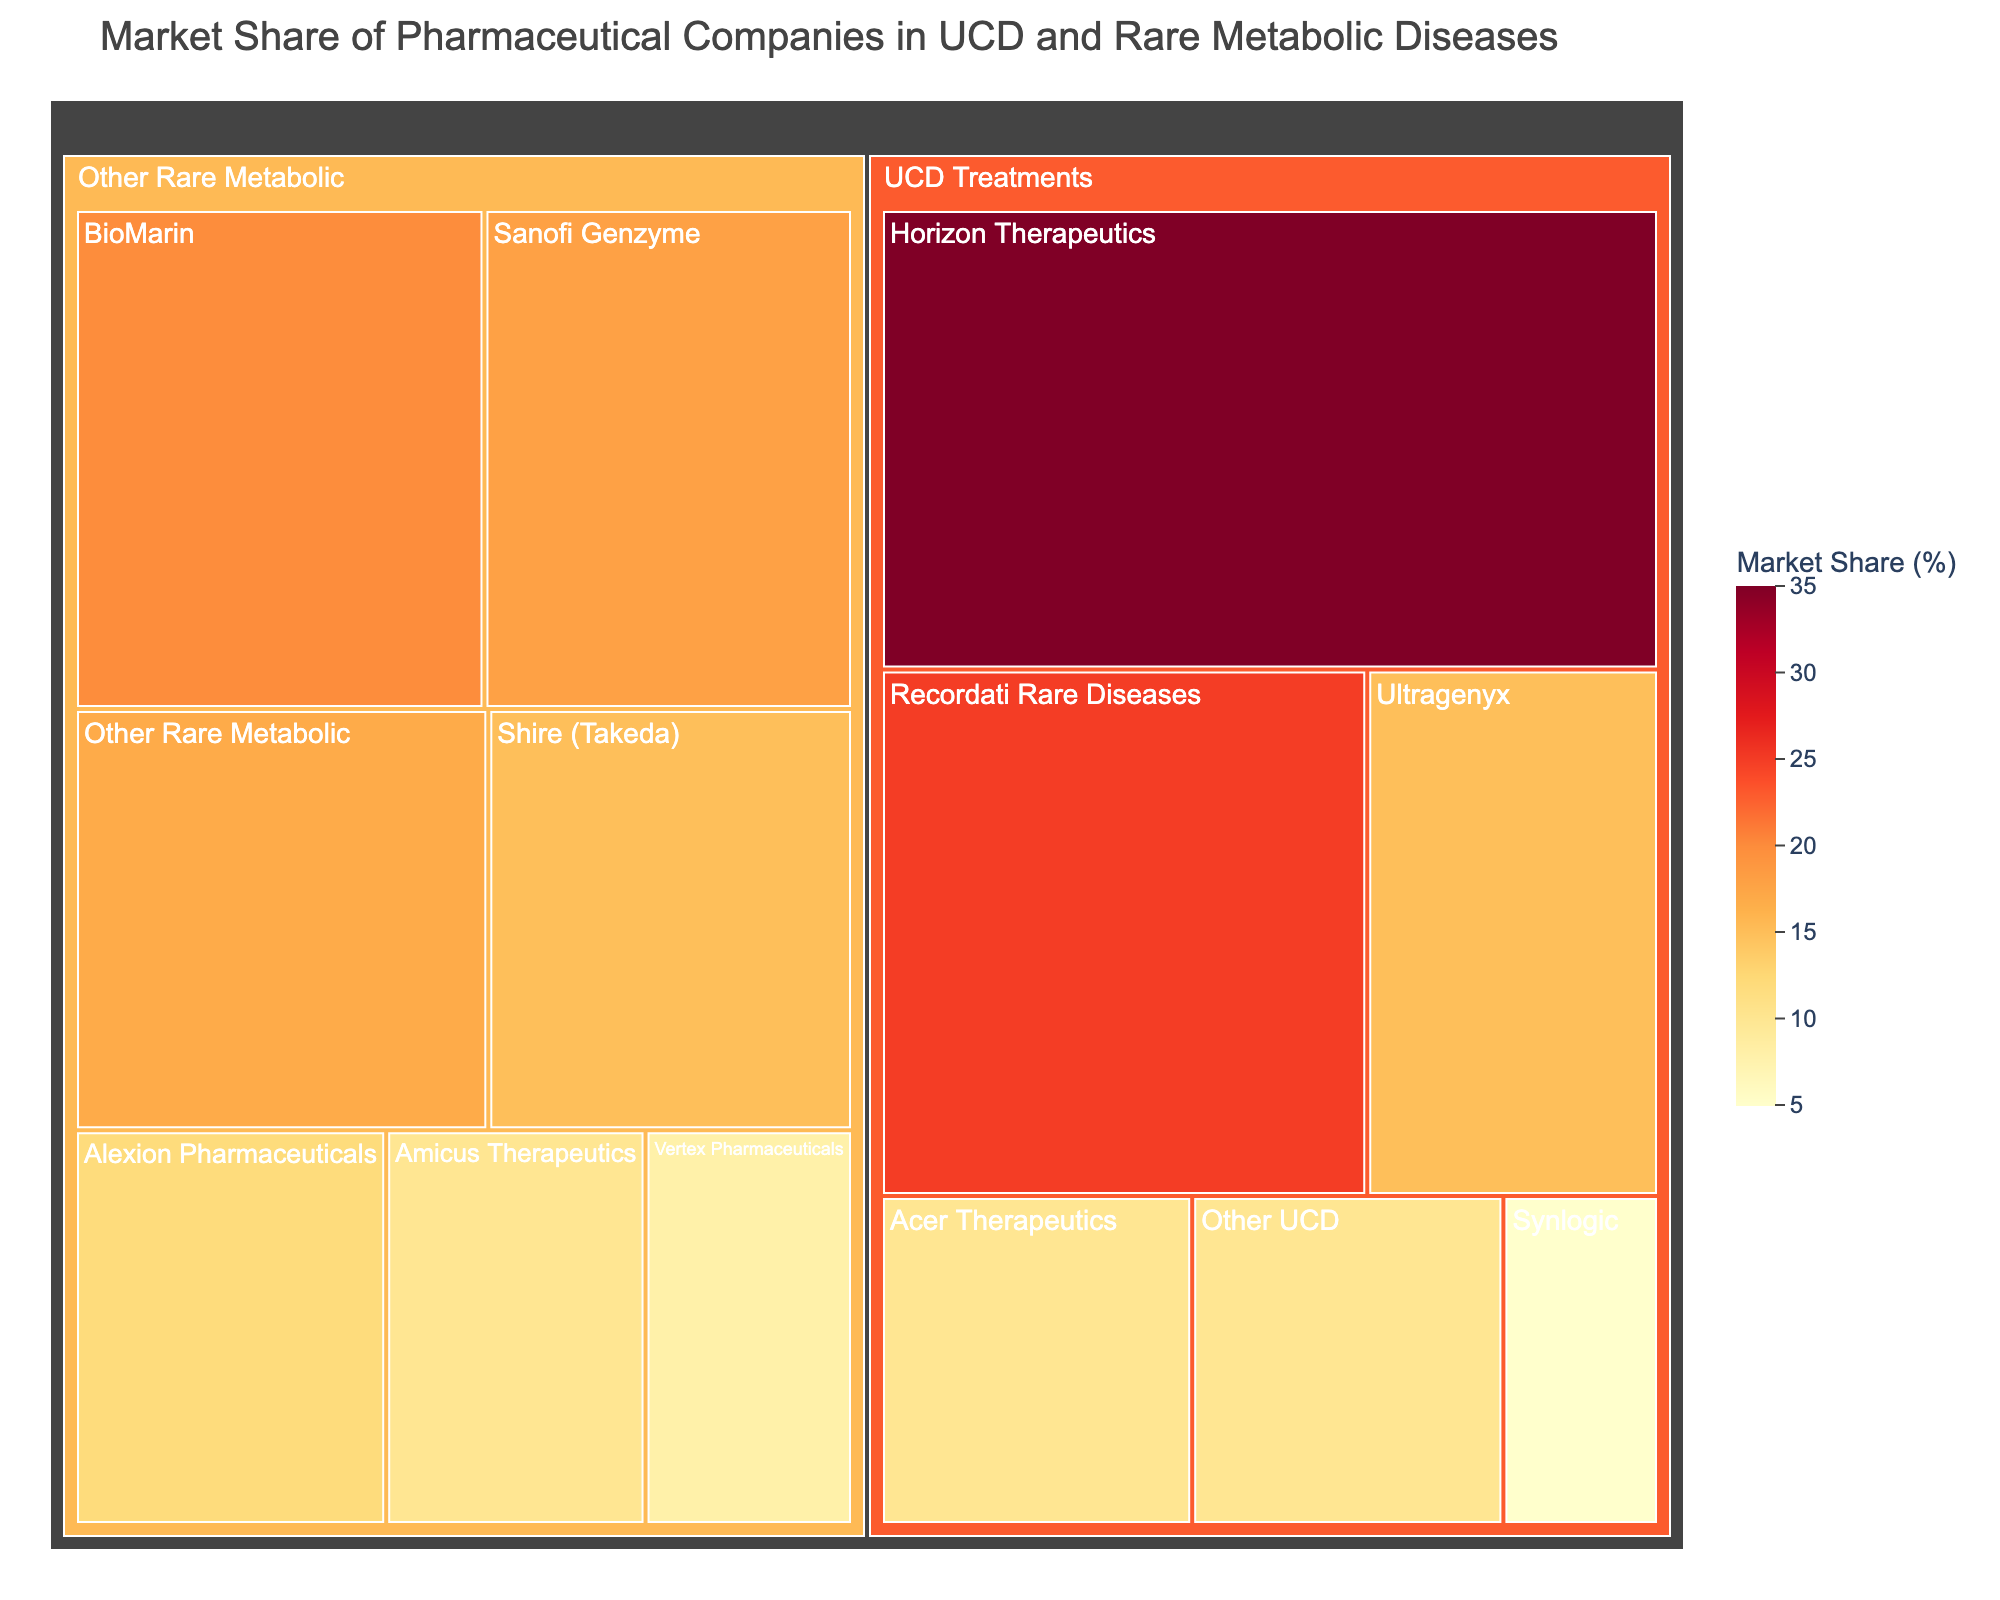What is the title of the treemap? The title is usually found at the top of the figure. It provides an overall description of what the figure represents. In this case, the title is "Market Share of Pharmaceutical Companies in UCD and Rare Metabolic Diseases".
Answer: Market Share of Pharmaceutical Companies in UCD and Rare Metabolic Diseases Which company has the largest market share in UCD treatments? The largest market share in the UCD Treatments category would be indicated by the largest area in that section of the treemap. Here, Horizon Therapeutics has the largest market share of 35%.
Answer: Horizon Therapeutics How much market share do Acer Therapeutics and Synlogic hold together in UCD treatments? To find their combined market share, sum the values for Acer Therapeutics (10%) and Synlogic (5%). 10% + 5% = 15%.
Answer: 15% Which company has a larger market share in other rare metabolic diseases, Sanofi Genzyme or Shire (Takeda)? Compare the market shares of Sanofi Genzyme (18%) and Shire (Takeda) (15%) in the Other Rare Metabolic Diseases category. Sanofi Genzyme has a larger share.
Answer: Sanofi Genzyme What is the total market share of all companies in the UCD Treatments category? Sum all the market shares in the UCD Treatments category: Horizon Therapeutics (35%) + Recordati Rare Diseases (25%) + Ultragenyx (15%) + Acer Therapeutics (10%) + Synlogic (5%) + Other UCD (10%). The total is 35 + 25 + 15 + 10 + 5 + 10 = 100%.
Answer: 100% Which two companies have the closest market shares in other rare metabolic diseases? Look for companies whose market shares are numerically closest in the Other Rare Metabolic Diseases category. BioMarin (20%) and Sanofi Genzyme (18%) have the smallest difference.
Answer: BioMarin and Sanofi Genzyme How does the market share of Horizon Therapeutics in UCD treatments compare to BioMarin in other rare metabolic diseases? Compare Horizon's 35% market share in UCD treatments to BioMarin's 20% market share in other rare metabolic diseases. Horizon has a larger share.
Answer: Horizon Therapeutics How many companies have a market share of 10% or more in UCD treatments? Count the companies in the UCD Treatments category that have a market share of at least 10%. These include Horizon Therapeutics (35%), Recordati Rare Diseases (25%), Ultragenyx (15%), and Acer Therapeutics (10%). There are 4 companies in total.
Answer: 4 What is the combined market share of the companies categorized as "Other" in both UCD treatments and other rare metabolic diseases? Sum the market shares of Other UCD (10%) and Other Rare Metabolic (17%). 10% + 17% = 27%.
Answer: 27% Which category has a larger total market share for the top three companies, UCD treatments or other rare metabolic diseases? For UCD treatments: Horizon Therapeutics (35%) + Recordati Rare Diseases (25%) + Ultragenyx (15%) = 75%. 
For other rare metabolic diseases: BioMarin (20%) + Sanofi Genzyme (18%) + Shire (Takeda) (15%) = 53%. UCD treatments have a larger total for the top three companies.
Answer: UCD Treatments 